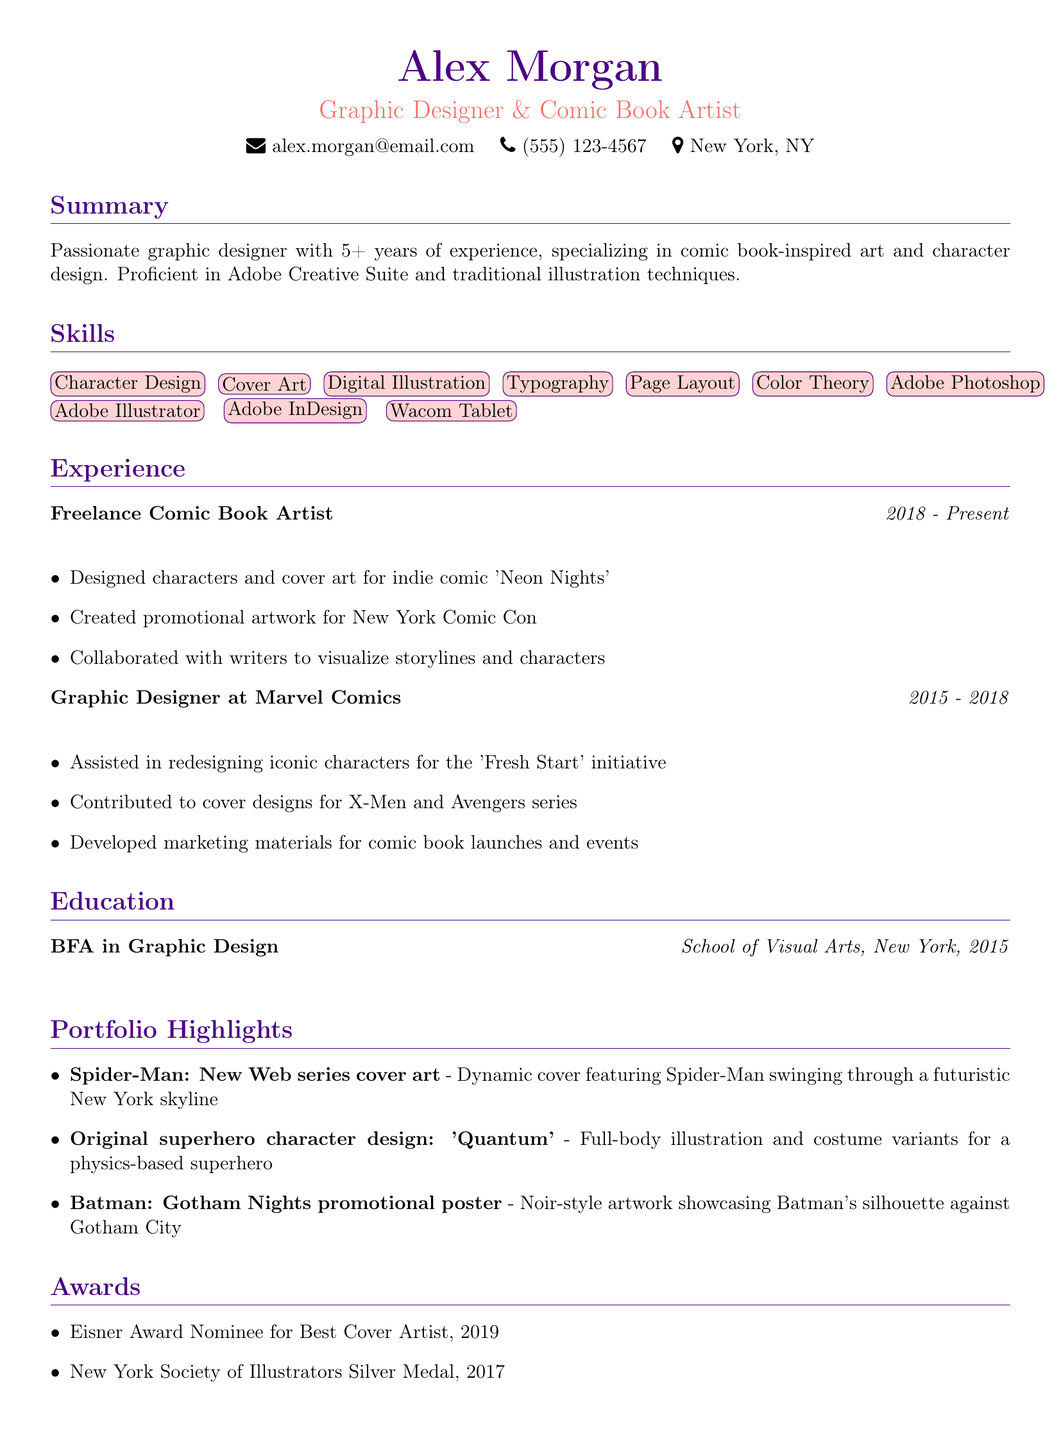what is the name of the individual? The name of the individual is listed at the top of the document.
Answer: Alex Morgan what is the title provided in the resume? The title is mentioned right below the individual's name.
Answer: Graphic Designer & Comic Book Artist how many years of experience does the individual have? The individual mentions their experience in the summary section of the document.
Answer: 5+ years which software is the individual proficient in according to the skills section? The skills section lists the software the individual is proficient in.
Answer: Adobe Creative Suite what was one of the highlights of the freelance comic book artist role? The experience section lists specific achievements during that role.
Answer: Designed characters and cover art for indie comic 'Neon Nights' which award did the individual get nominated for in 2019? The awards section specifies the nominations received by the individual.
Answer: Eisner Award Nominee for Best Cover Artist what is the title of one project listed in the portfolio? The portfolio section contains several project titles, indicating the individual's work.
Answer: Spider-Man: New Web series cover art where did the individual earn their degree? The education section provides the institution where the individual studied.
Answer: School of Visual Arts, New York 